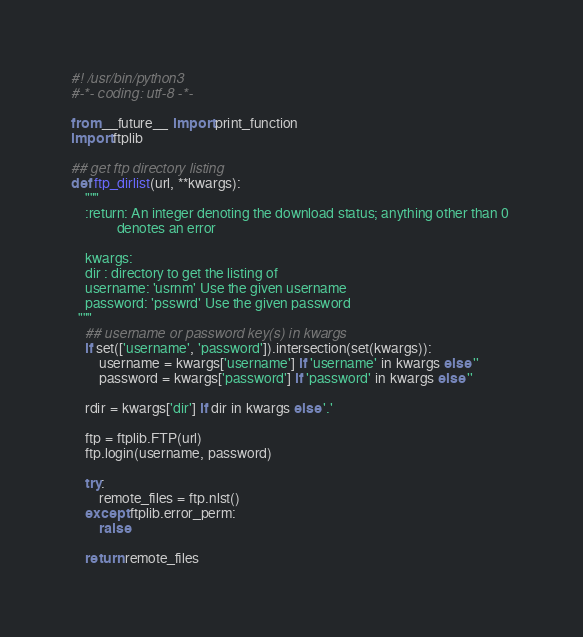Convert code to text. <code><loc_0><loc_0><loc_500><loc_500><_Python_>#! /usr/bin/python3
#-*- coding: utf-8 -*-

from __future__ import print_function
import ftplib

## get ftp directory listing
def ftp_dirlist(url, **kwargs):
    """
    :return: An integer denoting the download status; anything other than 0 
             denotes an error

    kwargs:
    dir : directory to get the listing of
    username: 'usrnm' Use the given username
    password: 'psswrd' Use the given password
  """
    ## username or password key(s) in kwargs
    if set(['username', 'password']).intersection(set(kwargs)):
        username = kwargs['username'] if 'username' in kwargs else ''
        password = kwargs['password'] if 'password' in kwargs else ''
    
    rdir = kwargs['dir'] if dir in kwargs else '.'

    ftp = ftplib.FTP(url)
    ftp.login(username, password)
    
    try:
        remote_files = ftp.nlst()
    except ftplib.error_perm:
        raise

    return remote_files
</code> 